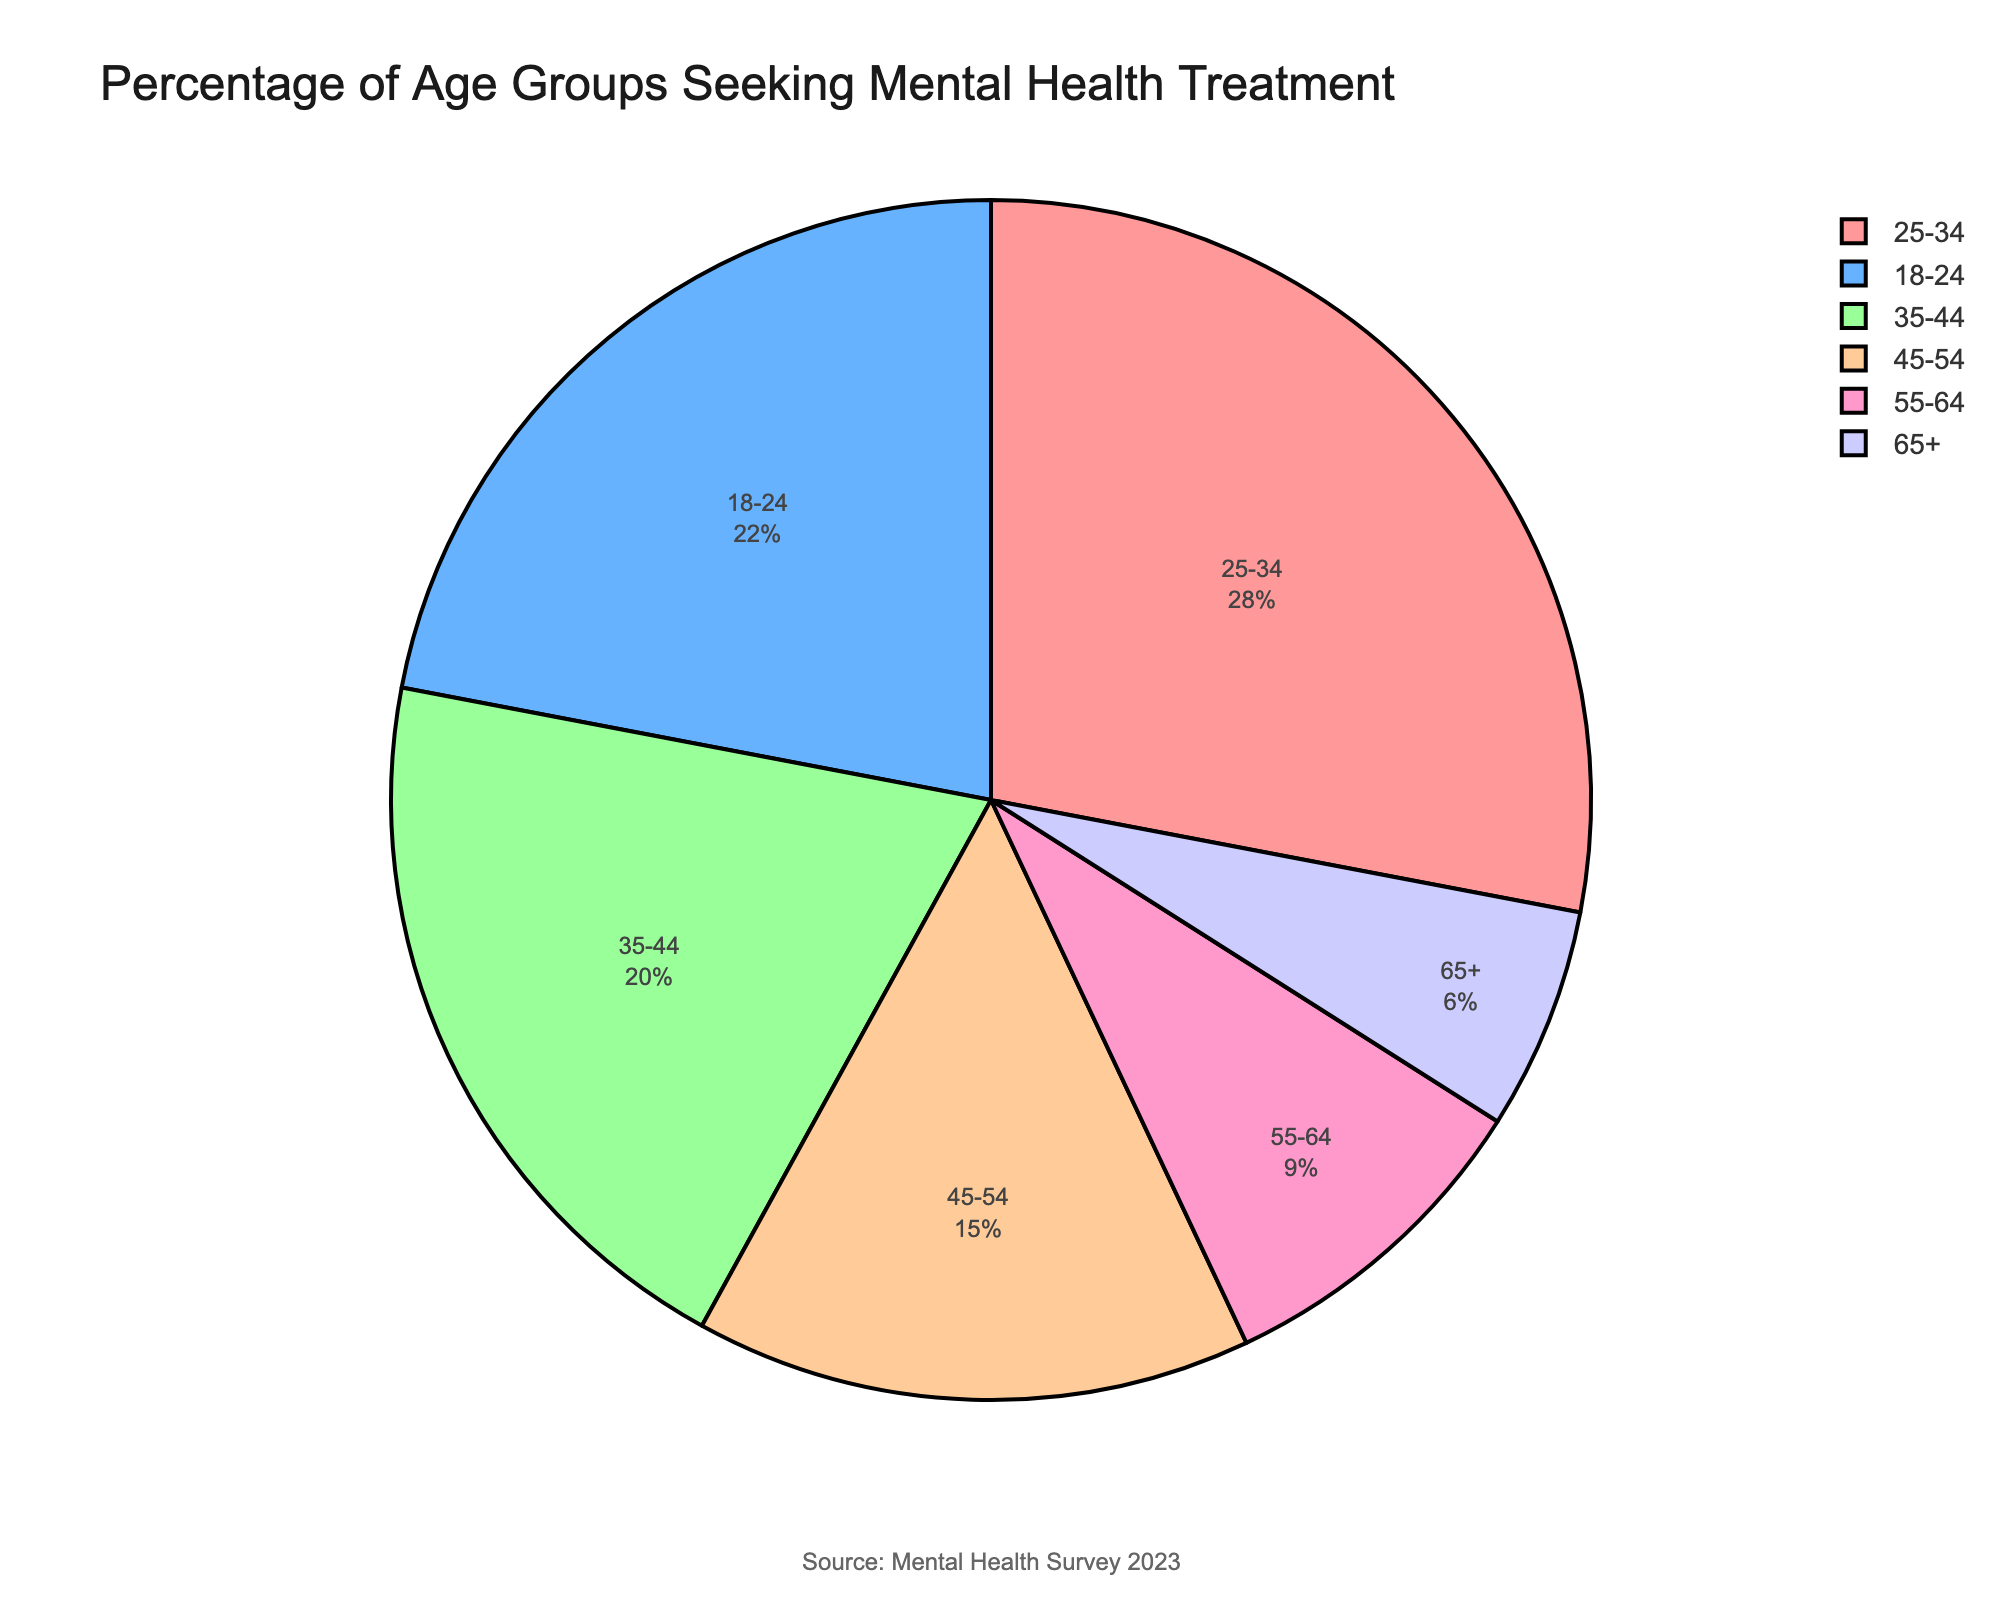What is the percentage of the age group 25-34 seeking mental health treatment? The figure shows the percentage of different age groups. Look at the slice labeled 25-34.
Answer: 28% Which age group has the lowest percentage seeking mental health treatment? The figure shows slices of different sizes for age groups. Identify the smallest slice.
Answer: 65+ What is the combined percentage of the age groups 18-24 and 45-54? Add the percentages of the 18-24 and 45-54 age groups. The figure shows 22% for 18-24 and 15% for 45-54. Combine these by 22 + 15.
Answer: 37% How many age groups have a percentage greater than 20%? From the figure, identify the slices where the percentage is greater than 20%.
Answer: 3 Compare the percentage of the age group 35-44 with 45-54. Which is higher, and by how much? From the figure, identify the percentages: 35-44 is 20% and 45-54 is 15%. Calculate the difference: 20 - 15.
Answer: 35-44, by 5% Which age group’s percentage is closest to 10%? Compare the percentages from the figure: 9% for 55-64 is closest to 10%.
Answer: 55-64 What is the average percentage of seeking mental health treatment across all age groups? Add all the percentages: 22 + 28 + 20 + 15 + 9 + 6, and divide by the number of age groups (6). The nominal sum is 100, so division will result in 100/6.
Answer: 16.67% Which age group has a pink-colored slice in the pie chart? Observe the color of the slices in the pie chart. The pink slice corresponds to 18-24.
Answer: 18-24 What is the difference between the highest and lowest percentage seeking mental health treatment? Identify the highest percentage (28% for 25-34) and the lowest percentage (6% for 65+). Subtract the smallest from the largest: 28 - 6.
Answer: 22% Which age group’s percentage is roughly twice as much as the 65+ age group? The percentage for 65+ age group is 6%. Identify any age group with approximately twice this percentage (12%). The 55-64 group (9%) is closest.
Answer: 55-64 